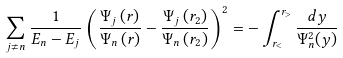<formula> <loc_0><loc_0><loc_500><loc_500>\sum _ { j \ne n } \frac { 1 } { E _ { n } - E _ { j } } \left ( \frac { \Psi _ { j } \left ( r \right ) } { \Psi _ { n } \left ( r \right ) } - \frac { \Psi _ { j } \left ( r _ { 2 } \right ) } { \Psi _ { n } \left ( r _ { 2 } \right ) } \right ) ^ { 2 } = - \int _ { r _ { < } } ^ { r _ { > } } \frac { d y } { \Psi _ { n } ^ { 2 } ( y ) }</formula> 